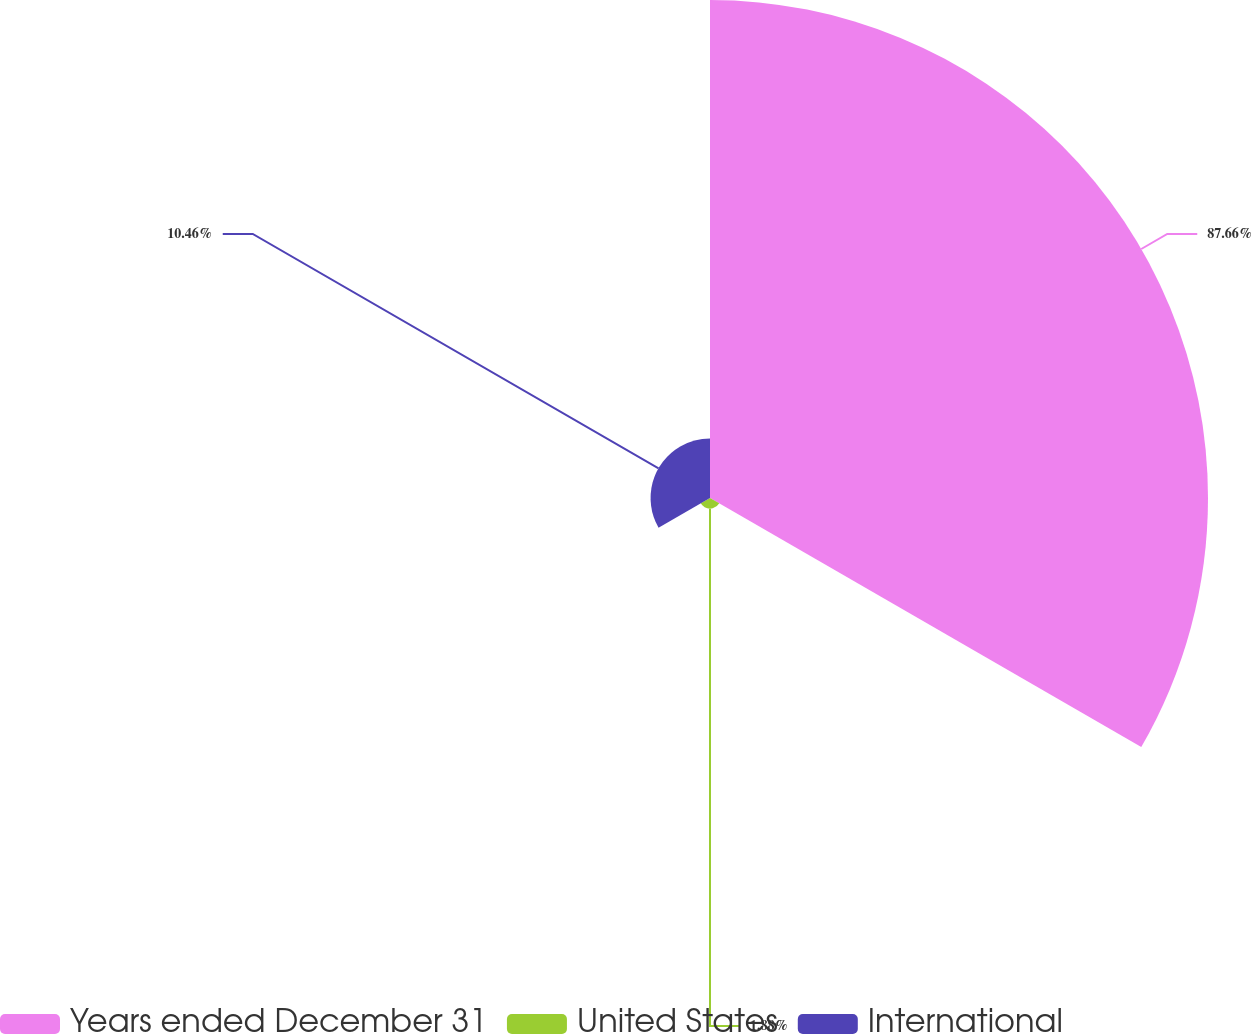<chart> <loc_0><loc_0><loc_500><loc_500><pie_chart><fcel>Years ended December 31<fcel>United States<fcel>International<nl><fcel>87.66%<fcel>1.88%<fcel>10.46%<nl></chart> 